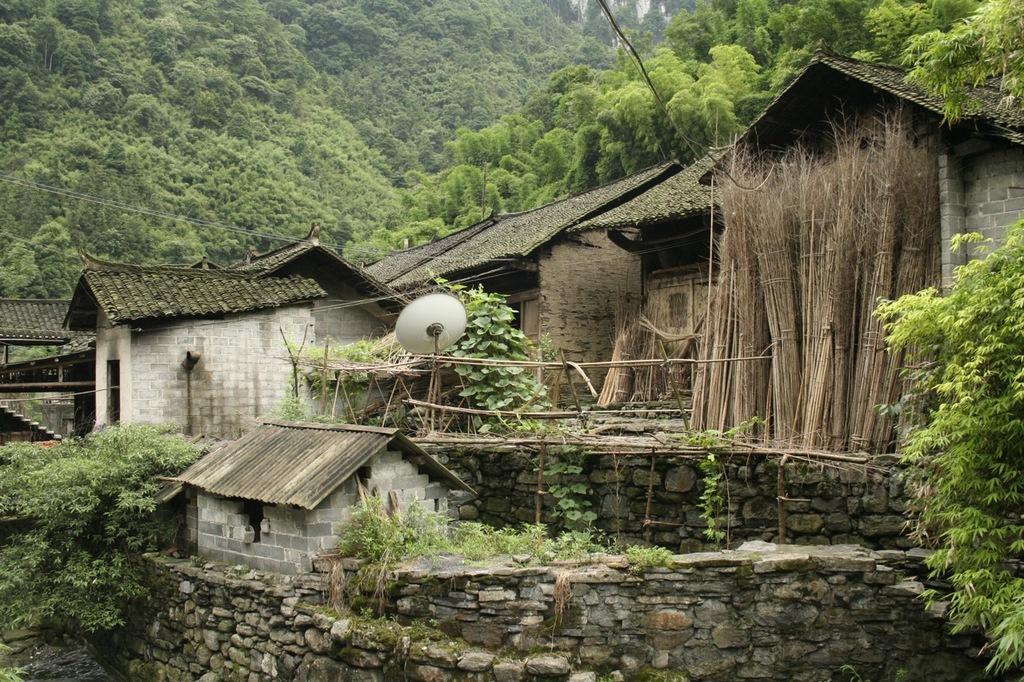How would you summarize this image in a sentence or two? In this picture I can see houses, there are plants, fence, there is a dish antenna and there are trees. 